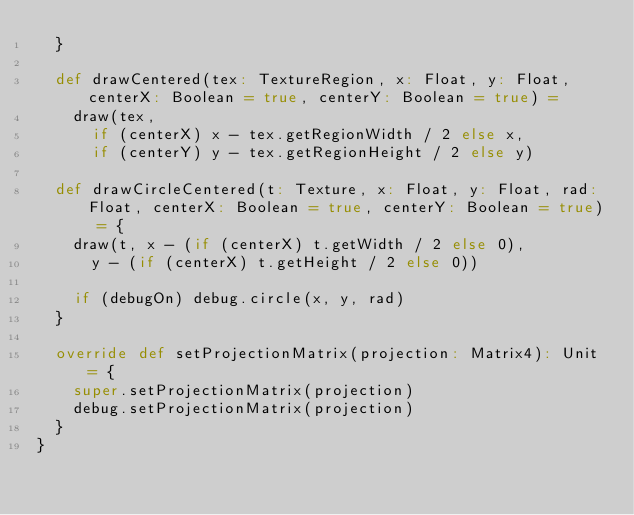Convert code to text. <code><loc_0><loc_0><loc_500><loc_500><_Scala_>  }

  def drawCentered(tex: TextureRegion, x: Float, y: Float, centerX: Boolean = true, centerY: Boolean = true) =
    draw(tex,
      if (centerX) x - tex.getRegionWidth / 2 else x,
      if (centerY) y - tex.getRegionHeight / 2 else y)

  def drawCircleCentered(t: Texture, x: Float, y: Float, rad: Float, centerX: Boolean = true, centerY: Boolean = true) = {
    draw(t, x - (if (centerX) t.getWidth / 2 else 0),
      y - (if (centerX) t.getHeight / 2 else 0))

    if (debugOn) debug.circle(x, y, rad)
  }

  override def setProjectionMatrix(projection: Matrix4): Unit = {
    super.setProjectionMatrix(projection)
    debug.setProjectionMatrix(projection)
  }
}
</code> 